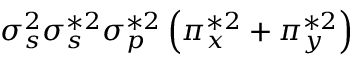Convert formula to latex. <formula><loc_0><loc_0><loc_500><loc_500>\sigma _ { s } ^ { 2 } \sigma _ { s } ^ { * 2 } \sigma _ { p } ^ { * 2 } \left ( \pi _ { x } ^ { * 2 } + \pi _ { y } ^ { * 2 } \right )</formula> 